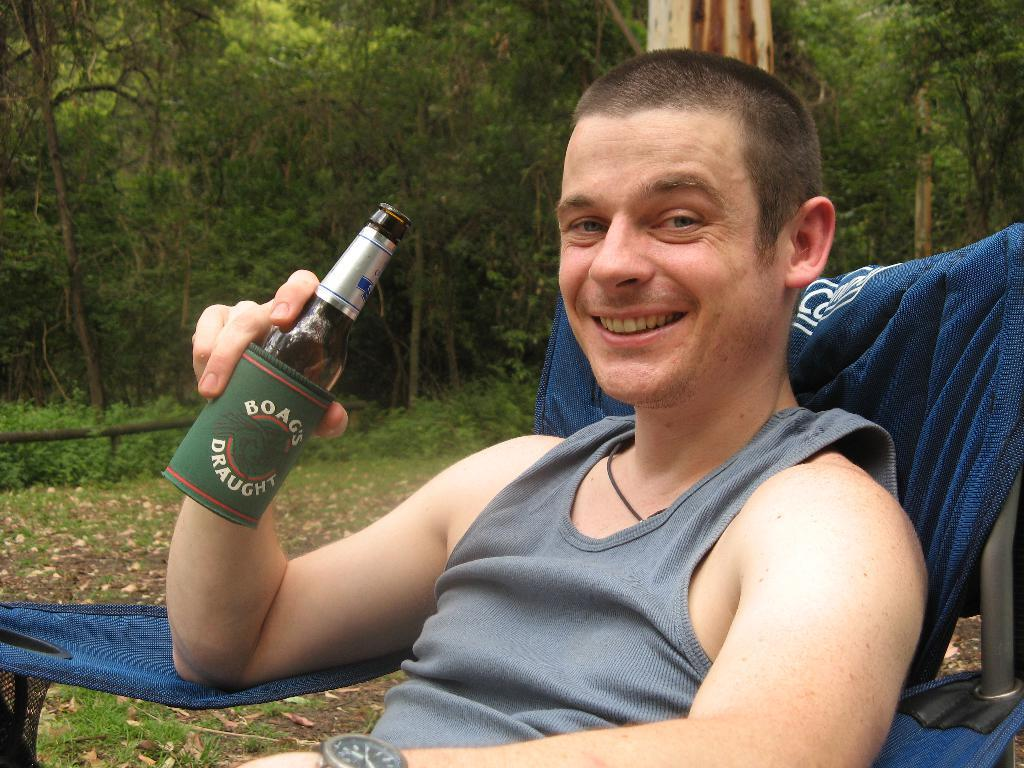What is the person in the image doing? There is a person sitting on a chair in the image. What is the person holding in their hands? The person is holding a bottle in their hands. What can be seen in the background of the image? There are trees visible in the background of the image. How many copies of the dust are visible on the cushion in the image? There is no dust or cushion present in the image. 